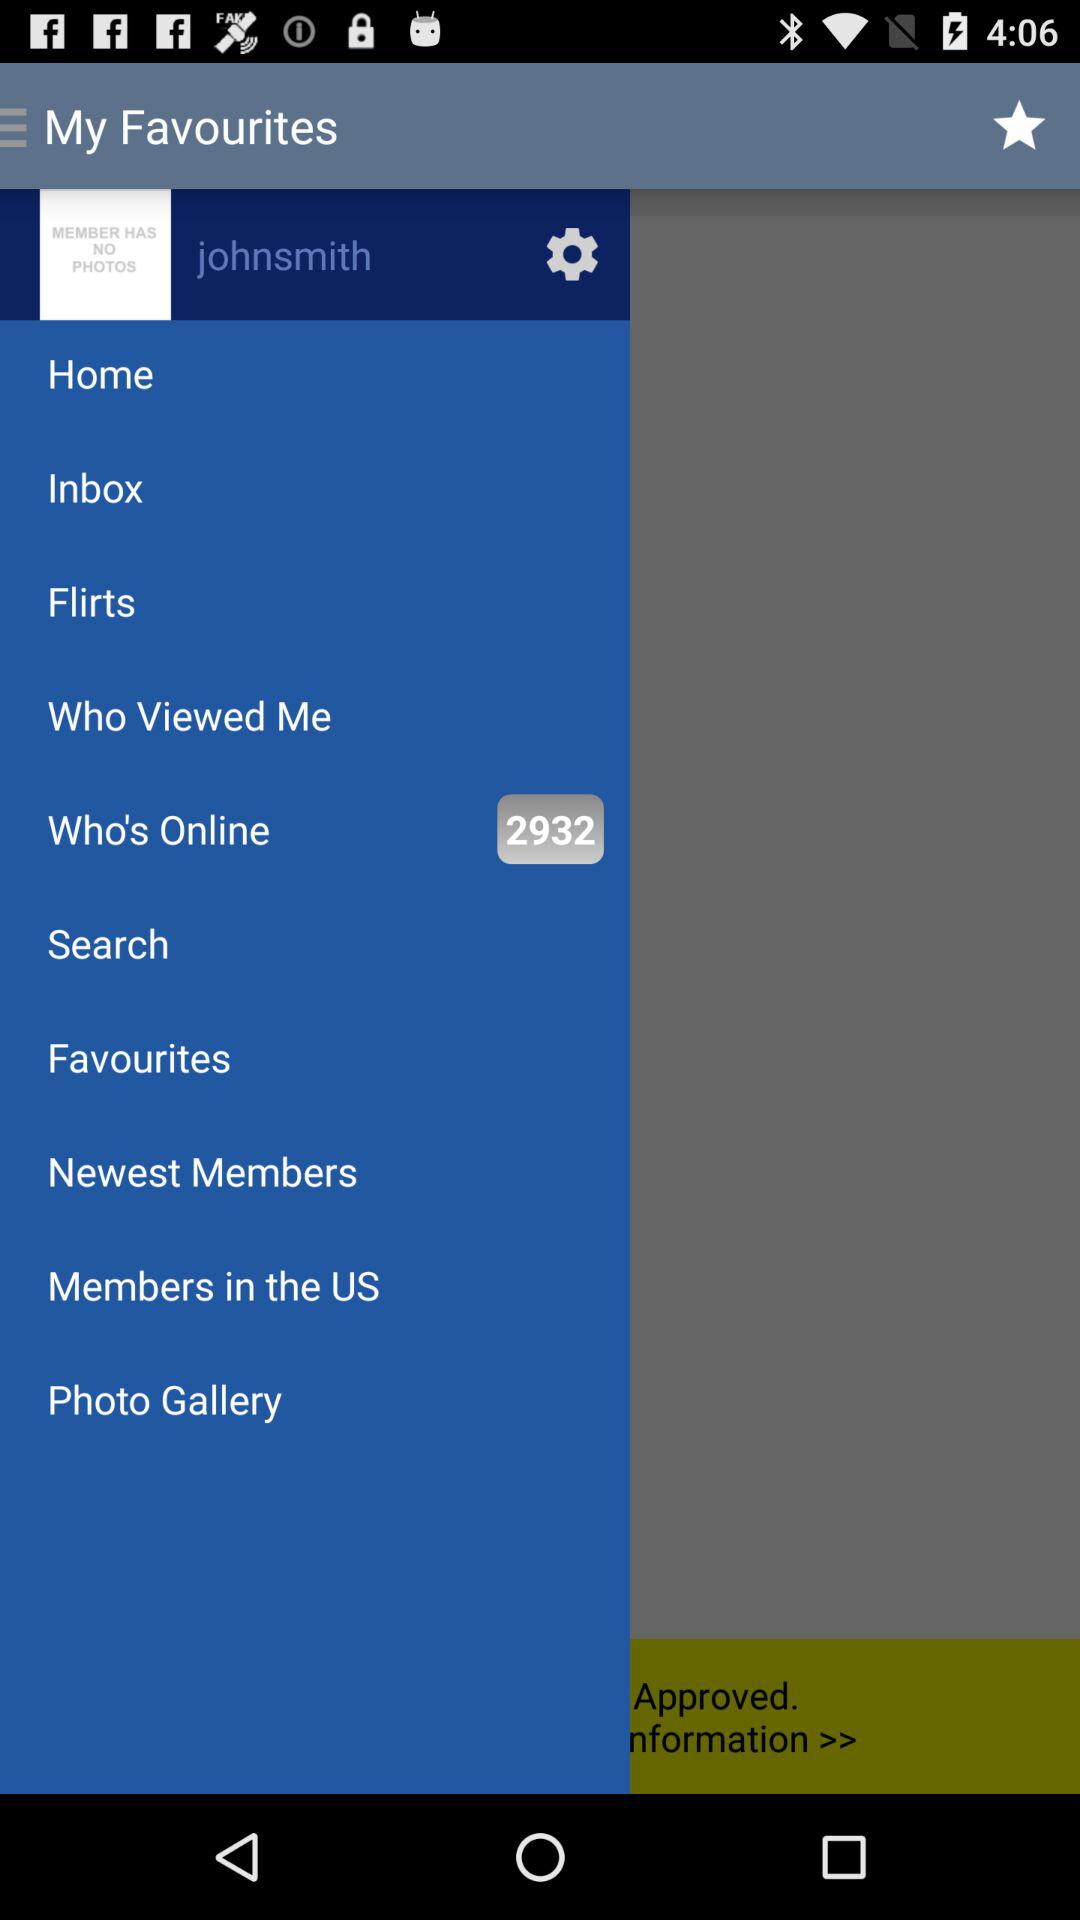How many notifications are there in "Flirts"?
When the provided information is insufficient, respond with <no answer>. <no answer> 